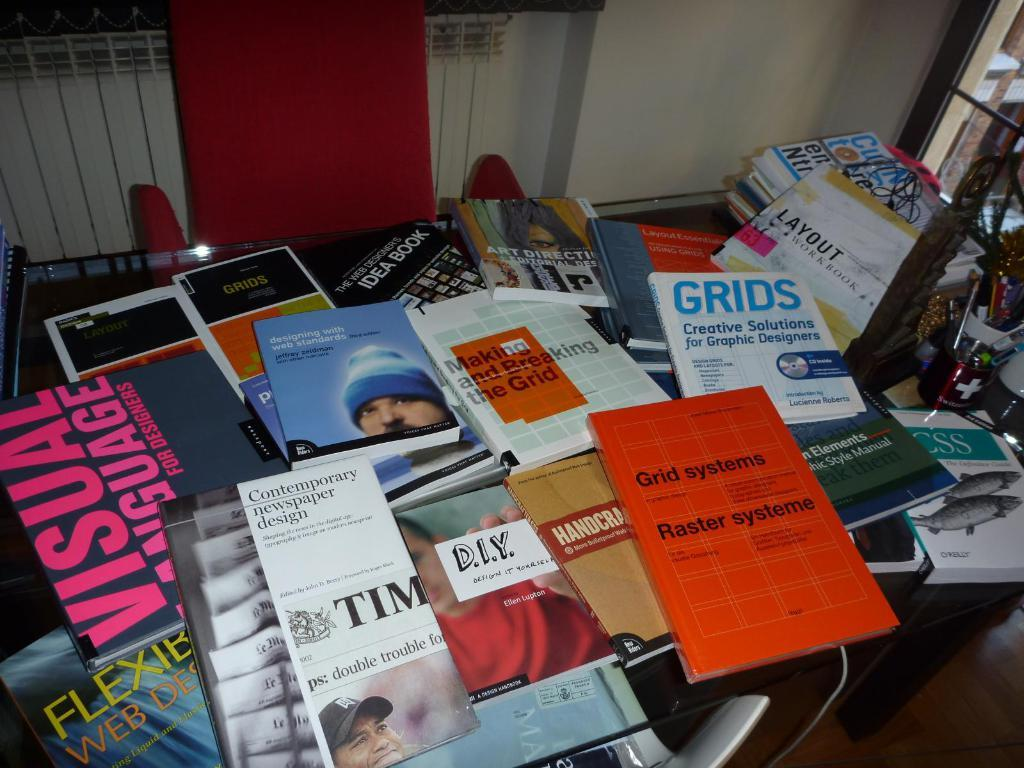<image>
Relay a brief, clear account of the picture shown. many web design and grid books and magazines are strung over the table 